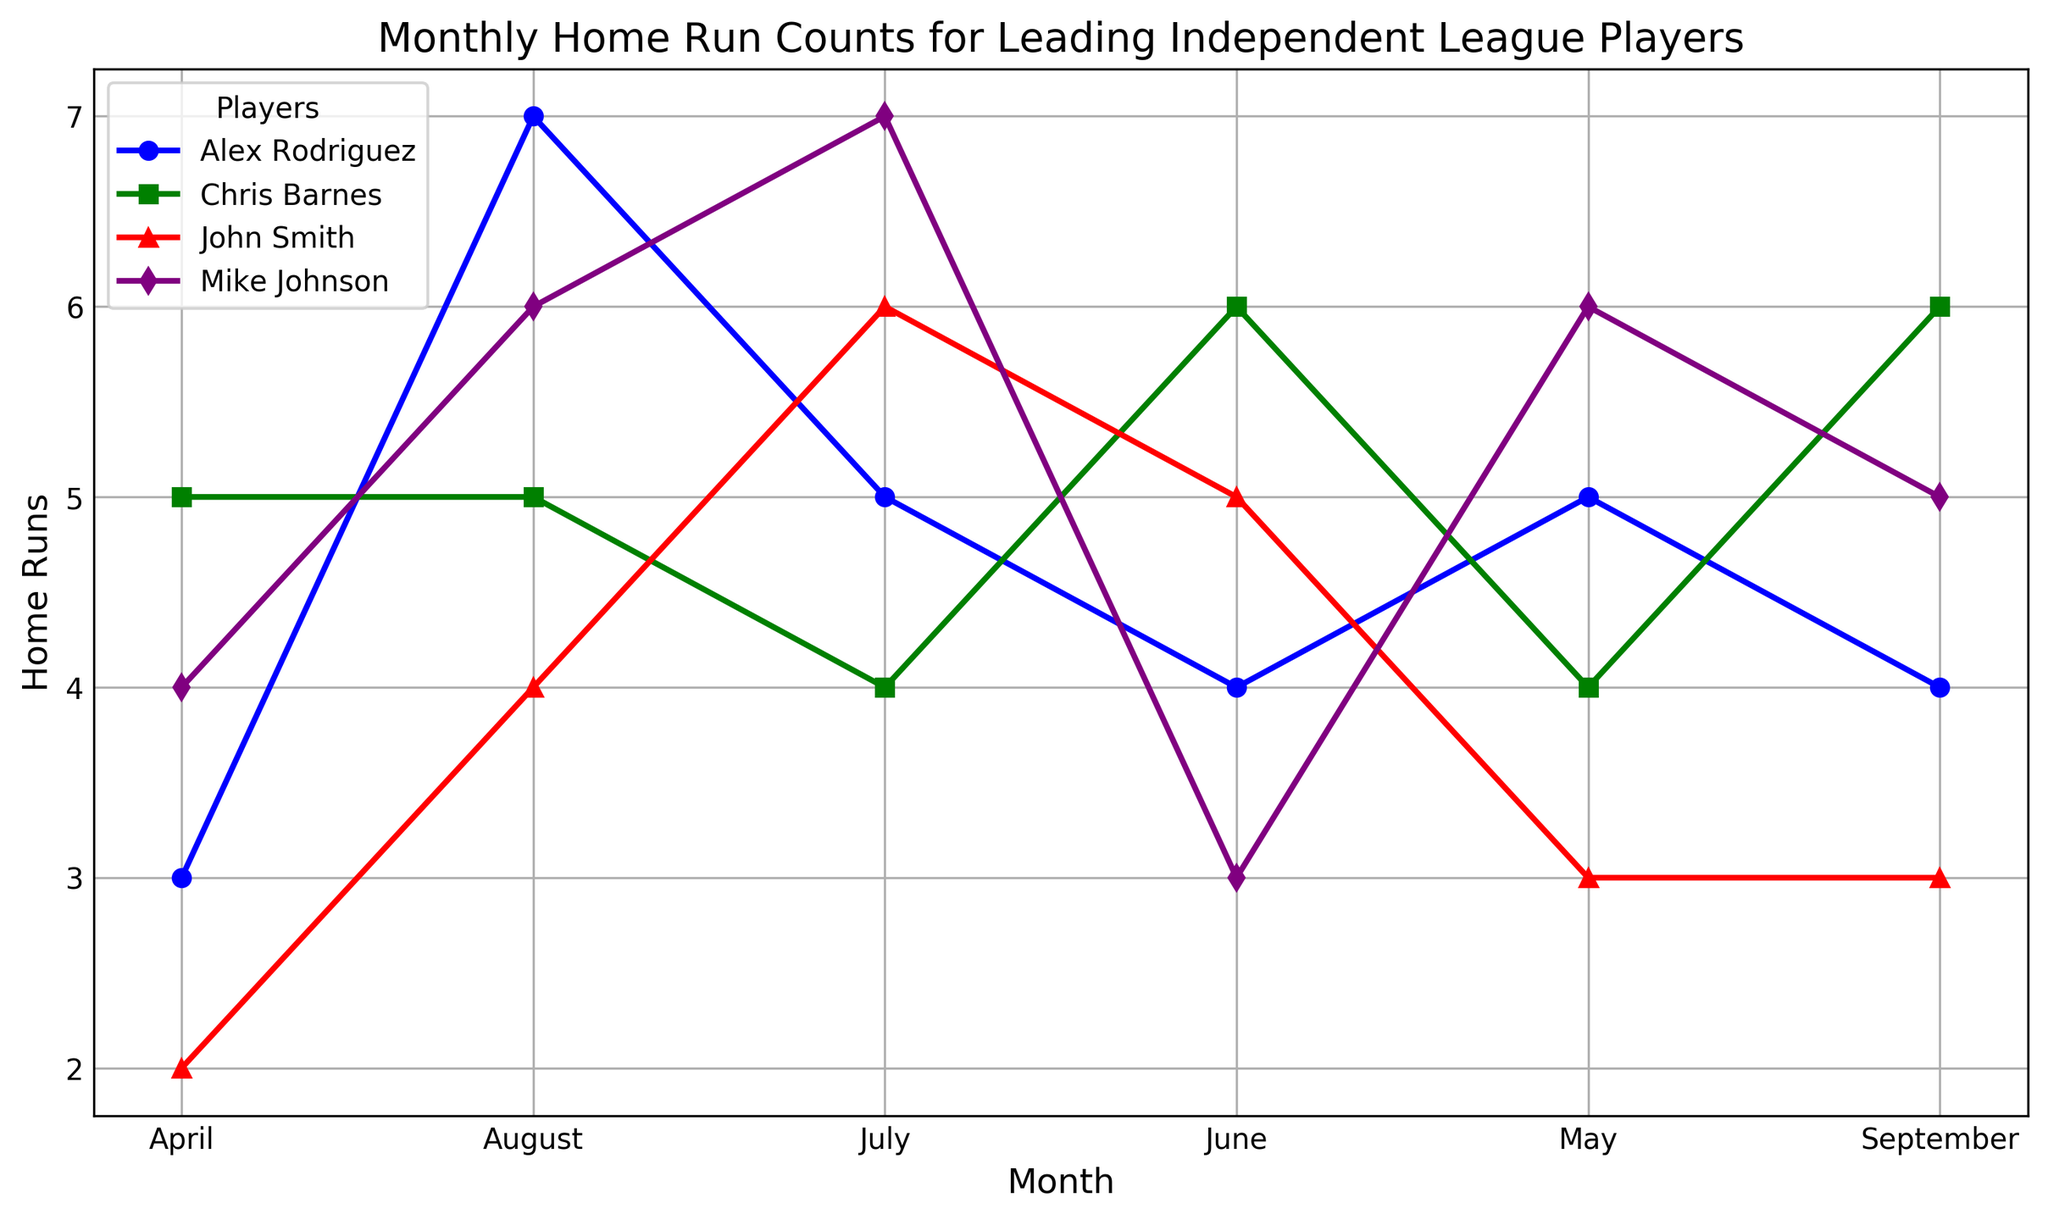Which player hit the most home runs in May? To find which player hit the most home runs in May, look at the data points for May on the x-axis and compare the corresponding values for each player. The highest value will indicate the player with the most home runs.
Answer: Mike Johnson Who had more home runs in July, John Smith or Chris Barnes? Look at the July values for both John Smith and Chris Barnes on the chart. Compare their heights to see which one is taller.
Answer: John Smith During which month did Alex Rodriguez have his highest home run count? Look at all the data points for Alex Rodriguez and identify the month where his count is the highest.
Answer: August What's the total number of home runs Chris Barnes hit in April and July? Sum the home run counts for Chris Barnes in April and July by locating these points on the chart for Chris Barnes.
Answer: 9 Which player showed the biggest increase in home run counts from April to May? Calculate the difference between May and April for each player. Identify the player with the highest positive difference.
Answer: Mike Johnson In which months did John Smith hit fewer than 4 home runs? Look at the data points for John Smith and identify which months have a count less than 4.
Answer: April and September Who had the highest cumulative home runs from June to August? Add the home run counts from June, July, and August for each player and compare the totals to find the highest cumulative.
Answer: Alex Rodriguez How does the home run count of Mike Johnson in June compare to his count in May? Compare the values for Mike Johnson in June and May on the chart. Determine if the count is higher, lower, or the same.
Answer: Lower Which player had the most consistent monthly home run count? Check the variability in the monthly home run counts for each player and identify the player with the least fluctuation.
Answer: Alex Rodriguez What's the total difference in home runs between Alex Rodriguez and John Smith by the end of the season? Calculate the total home runs for both players from April to September and subtract the total of John Smith from Alex Rodriguez's total.
Answer: 5 